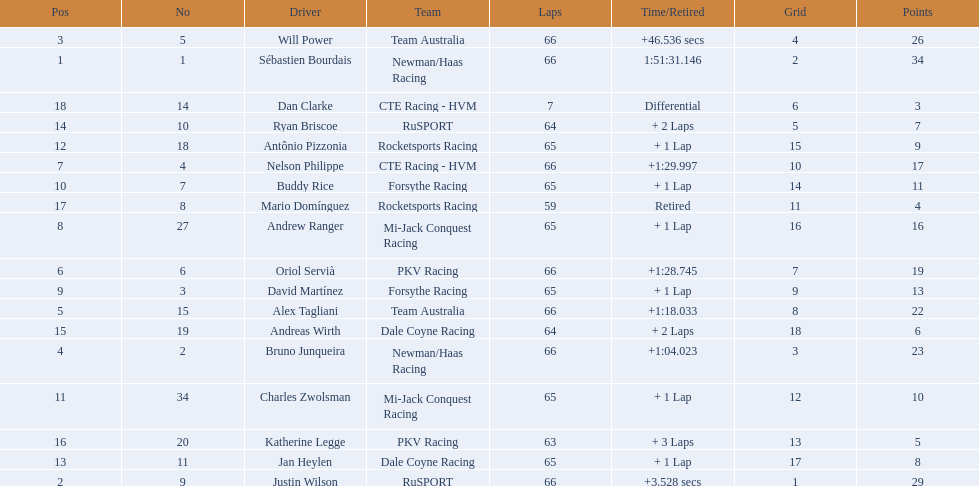How many points did first place receive? 34. How many did last place receive? 3. Who was the recipient of these last place points? Dan Clarke. 